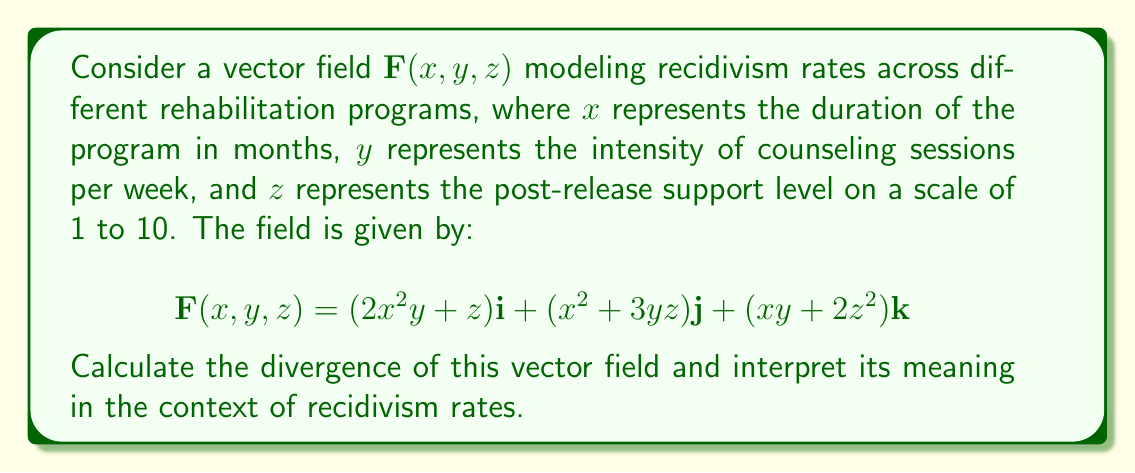Teach me how to tackle this problem. To solve this problem, we'll follow these steps:

1) The divergence of a vector field $\mathbf{F}(x, y, z) = P\mathbf{i} + Q\mathbf{j} + R\mathbf{k}$ is given by:

   $$\nabla \cdot \mathbf{F} = \frac{\partial P}{\partial x} + \frac{\partial Q}{\partial y} + \frac{\partial R}{\partial z}$$

2) In our case:
   $P = 2x^2y + z$
   $Q = x^2 + 3yz$
   $R = xy + 2z^2$

3) Let's calculate each partial derivative:

   $\frac{\partial P}{\partial x} = \frac{\partial}{\partial x}(2x^2y + z) = 4xy$

   $\frac{\partial Q}{\partial y} = \frac{\partial}{\partial y}(x^2 + 3yz) = 3z$

   $\frac{\partial R}{\partial z} = \frac{\partial}{\partial z}(xy + 2z^2) = 4z$

4) Now, we sum these partial derivatives:

   $$\nabla \cdot \mathbf{F} = 4xy + 3z + 4z = 4xy + 7z$$

5) Interpretation: The divergence represents the rate at which recidivism is changing with respect to the program parameters at each point. A positive divergence indicates an increase in recidivism rates, while a negative divergence indicates a decrease.

   In this case, the divergence is positive when either:
   a) $xy > 0$ and its magnitude is greater than $-\frac{7}{4}z$, or
   b) $z > 0$ and its magnitude is greater than $-\frac{4}{7}xy$

   This suggests that longer, more intensive programs (larger $x$ and $y$) tend to increase recidivism rates, which is counterintuitive. However, higher levels of post-release support (larger $z$) also contribute to increased recidivism rates, which could indicate that those receiving more support were initially at higher risk of reoffending.

   The model implies that the most effective approach to reducing recidivism might be shorter, less intensive programs with moderate post-release support, which could be an interesting point for policy consideration.
Answer: $\nabla \cdot \mathbf{F} = 4xy + 7z$ 